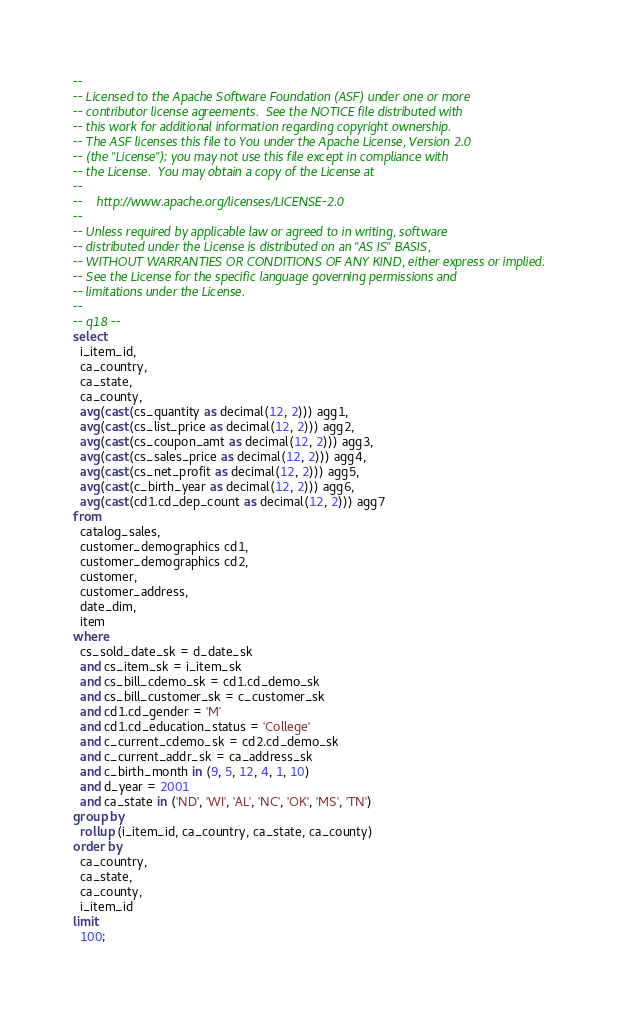<code> <loc_0><loc_0><loc_500><loc_500><_SQL_>--
-- Licensed to the Apache Software Foundation (ASF) under one or more
-- contributor license agreements.  See the NOTICE file distributed with
-- this work for additional information regarding copyright ownership.
-- The ASF licenses this file to You under the Apache License, Version 2.0
-- (the "License"); you may not use this file except in compliance with
-- the License.  You may obtain a copy of the License at
--
--    http://www.apache.org/licenses/LICENSE-2.0
--
-- Unless required by applicable law or agreed to in writing, software
-- distributed under the License is distributed on an "AS IS" BASIS,
-- WITHOUT WARRANTIES OR CONDITIONS OF ANY KIND, either express or implied.
-- See the License for the specific language governing permissions and
-- limitations under the License.
--
-- q18 --
select
  i_item_id,
  ca_country,
  ca_state,
  ca_county,
  avg(cast(cs_quantity as decimal(12, 2))) agg1,
  avg(cast(cs_list_price as decimal(12, 2))) agg2,
  avg(cast(cs_coupon_amt as decimal(12, 2))) agg3,
  avg(cast(cs_sales_price as decimal(12, 2))) agg4,
  avg(cast(cs_net_profit as decimal(12, 2))) agg5,
  avg(cast(c_birth_year as decimal(12, 2))) agg6,
  avg(cast(cd1.cd_dep_count as decimal(12, 2))) agg7
from
  catalog_sales,
  customer_demographics cd1,
  customer_demographics cd2,
  customer,
  customer_address,
  date_dim,
  item
where
  cs_sold_date_sk = d_date_sk
  and cs_item_sk = i_item_sk
  and cs_bill_cdemo_sk = cd1.cd_demo_sk
  and cs_bill_customer_sk = c_customer_sk
  and cd1.cd_gender = 'M'
  and cd1.cd_education_status = 'College'
  and c_current_cdemo_sk = cd2.cd_demo_sk
  and c_current_addr_sk = ca_address_sk
  and c_birth_month in (9, 5, 12, 4, 1, 10)
  and d_year = 2001
  and ca_state in ('ND', 'WI', 'AL', 'NC', 'OK', 'MS', 'TN')
group by
  rollup (i_item_id, ca_country, ca_state, ca_county)
order by
  ca_country,
  ca_state,
  ca_county,
  i_item_id
limit
  100;
</code> 